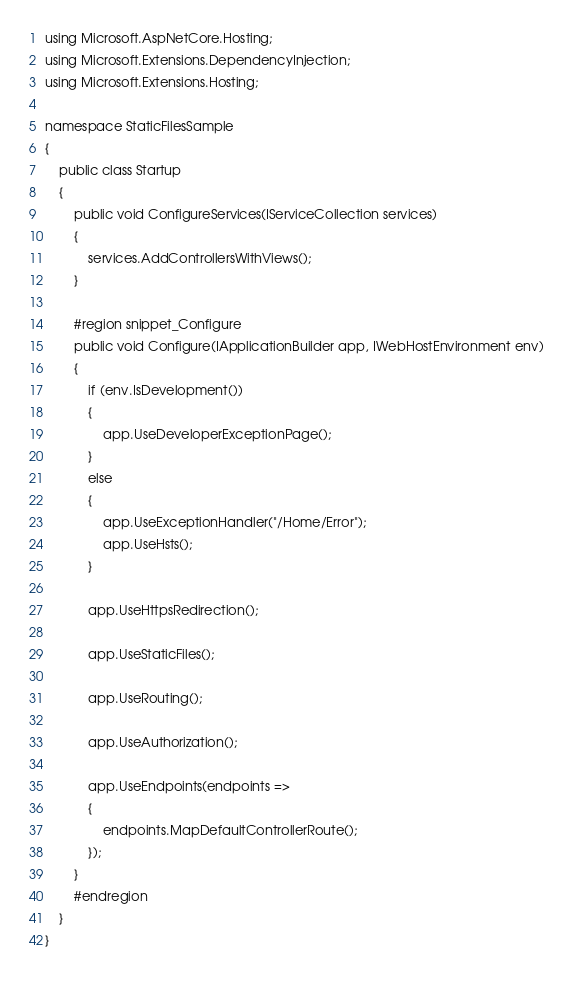Convert code to text. <code><loc_0><loc_0><loc_500><loc_500><_C#_>using Microsoft.AspNetCore.Hosting;
using Microsoft.Extensions.DependencyInjection;
using Microsoft.Extensions.Hosting;

namespace StaticFilesSample
{
    public class Startup
    {
        public void ConfigureServices(IServiceCollection services)
        {
            services.AddControllersWithViews();
        }

        #region snippet_Configure
        public void Configure(IApplicationBuilder app, IWebHostEnvironment env)
        {
            if (env.IsDevelopment())
            {
                app.UseDeveloperExceptionPage();
            }
            else
            {
                app.UseExceptionHandler("/Home/Error");
                app.UseHsts();
            }

            app.UseHttpsRedirection();

            app.UseStaticFiles();

            app.UseRouting();

            app.UseAuthorization();

            app.UseEndpoints(endpoints =>
            {
                endpoints.MapDefaultControllerRoute();
            });
        }
        #endregion
    }
}
</code> 